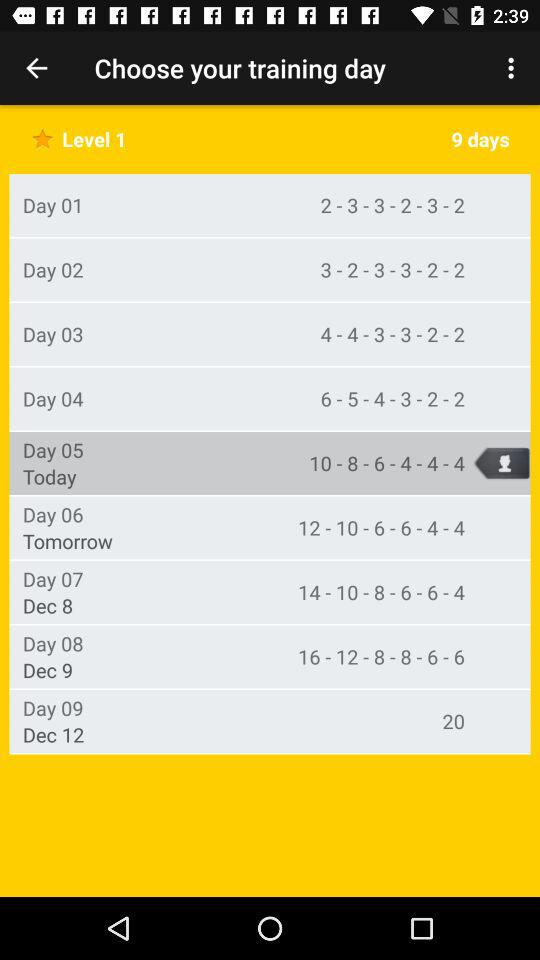How many days are in the current training program?
Answer the question using a single word or phrase. 9 